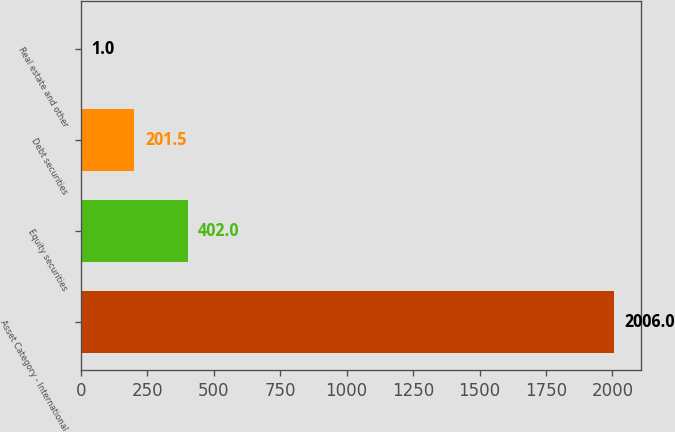<chart> <loc_0><loc_0><loc_500><loc_500><bar_chart><fcel>Asset Category - International<fcel>Equity securities<fcel>Debt securities<fcel>Real estate and other<nl><fcel>2006<fcel>402<fcel>201.5<fcel>1<nl></chart> 